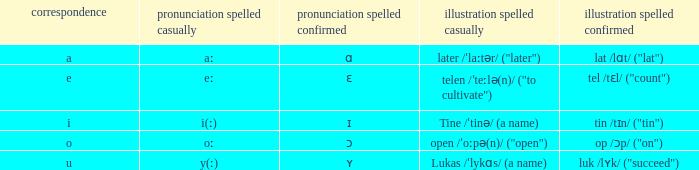What is Pronunciation Spelled Checked, when Example Spelled Checked is "tin /tɪn/ ("tin")" Ɪ. 